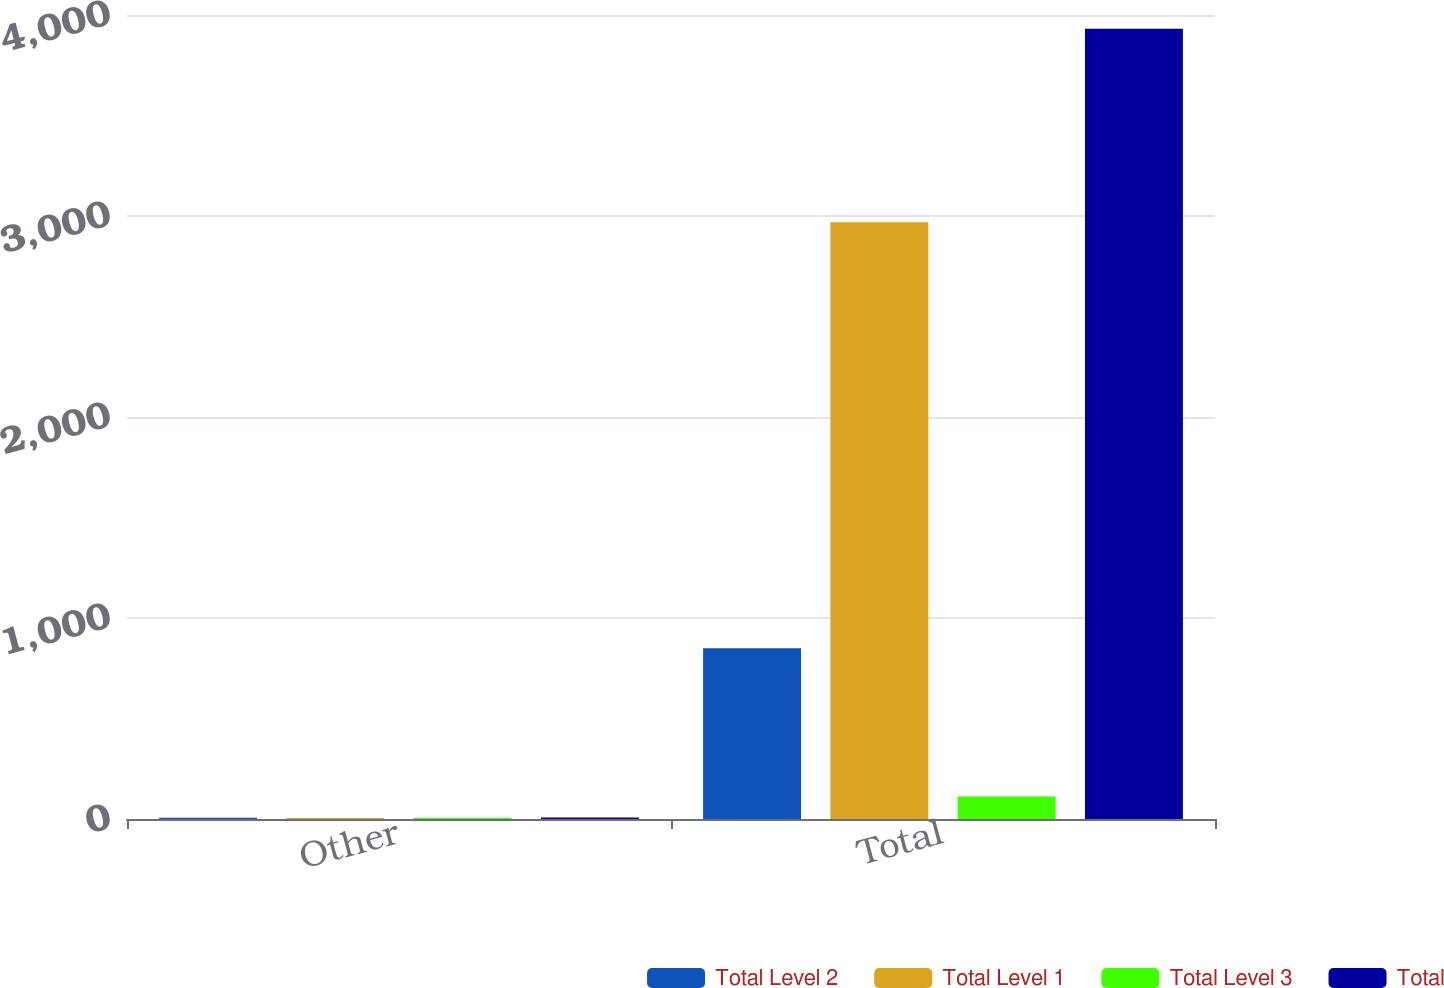Convert chart to OTSL. <chart><loc_0><loc_0><loc_500><loc_500><stacked_bar_chart><ecel><fcel>Other<fcel>Total<nl><fcel>Total Level 2<fcel>6<fcel>850<nl><fcel>Total Level 1<fcel>5<fcel>2969<nl><fcel>Total Level 3<fcel>6<fcel>112<nl><fcel>Total<fcel>7<fcel>3931<nl></chart> 